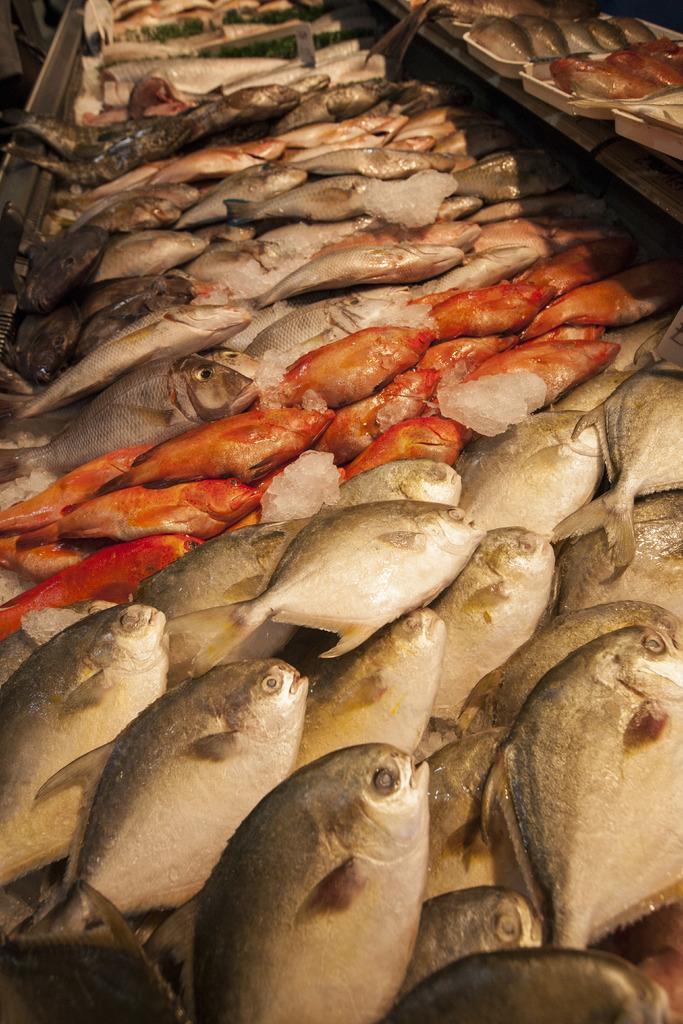Please provide a concise description of this image. In this image, we can see fishes and rock salt pieces. On the right side top corner, we can see few fishes in the trays. Left side top corner, we can see an object. 